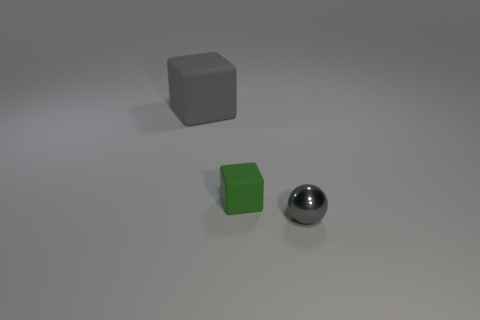What color is the other cube that is made of the same material as the tiny cube?
Give a very brief answer. Gray. There is another large object that is the same shape as the green thing; what material is it?
Give a very brief answer. Rubber. Does the large thing have the same color as the tiny sphere?
Your answer should be very brief. Yes. The other thing that is made of the same material as the large object is what size?
Ensure brevity in your answer.  Small. There is a small object to the left of the small gray object; are there any green matte blocks that are behind it?
Provide a short and direct response. No. Do the matte cube on the right side of the large gray object and the gray thing in front of the small green matte object have the same size?
Ensure brevity in your answer.  Yes. How many tiny things are either balls or gray matte objects?
Provide a succinct answer. 1. The gray thing to the left of the gray object in front of the big matte thing is made of what material?
Make the answer very short. Rubber. There is a thing that is the same color as the large rubber cube; what is its shape?
Offer a very short reply. Sphere. Is there a cyan cube that has the same material as the tiny gray ball?
Your answer should be very brief. No. 